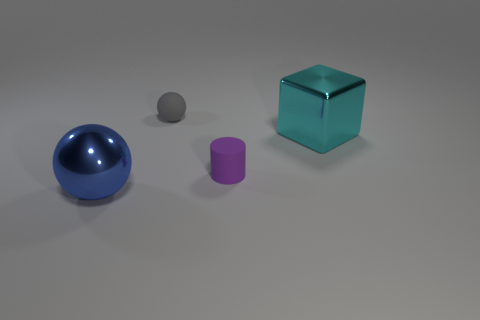Subtract all cylinders. How many objects are left? 3 Add 4 large cyan shiny objects. How many objects exist? 8 Subtract 1 cylinders. How many cylinders are left? 0 Subtract all gray cubes. Subtract all cyan spheres. How many cubes are left? 1 Subtract all cyan cubes. How many gray spheres are left? 1 Subtract all purple rubber objects. Subtract all cyan things. How many objects are left? 2 Add 2 gray matte things. How many gray matte things are left? 3 Add 1 small green cubes. How many small green cubes exist? 1 Subtract 0 green spheres. How many objects are left? 4 